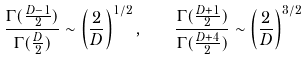<formula> <loc_0><loc_0><loc_500><loc_500>\frac { \Gamma ( \frac { D - 1 } { 2 } ) } { \Gamma ( \frac { D } { 2 } ) } \sim \left ( \frac { 2 } { D } \right ) ^ { 1 / 2 } , \quad \frac { \Gamma ( \frac { D + 1 } { 2 } ) } { \Gamma ( \frac { D + 4 } { 2 } ) } \sim \left ( \frac { 2 } { D } \right ) ^ { 3 / 2 }</formula> 